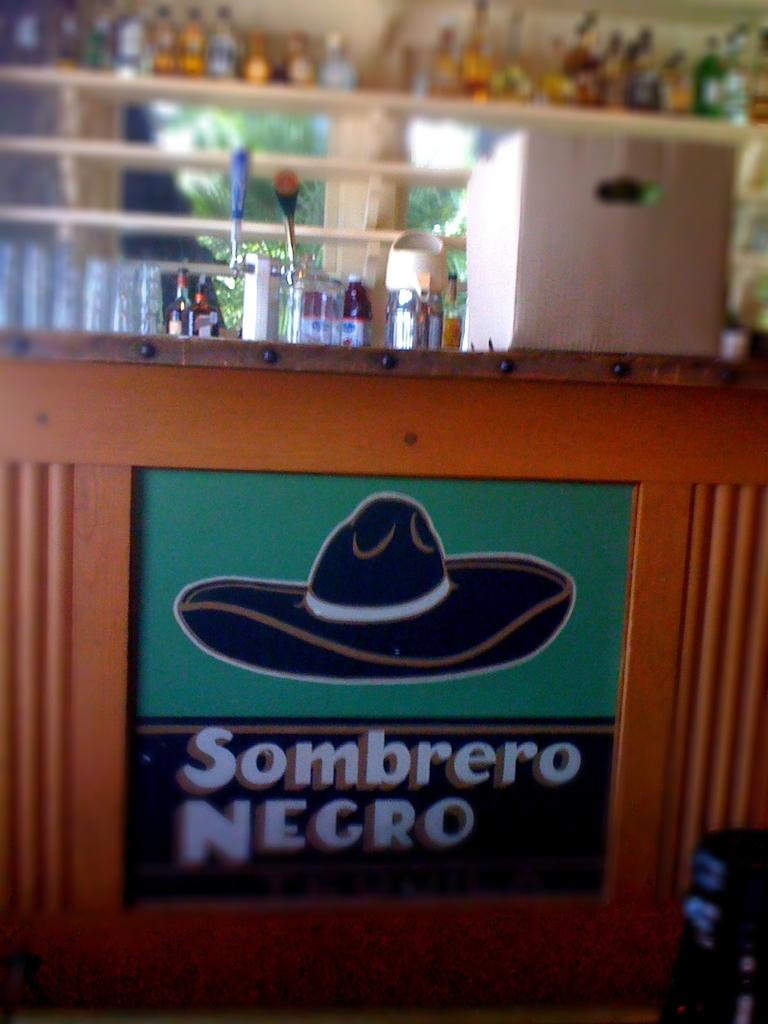<image>
Relay a brief, clear account of the picture shown. A ad on bar for sombrero begro beer 